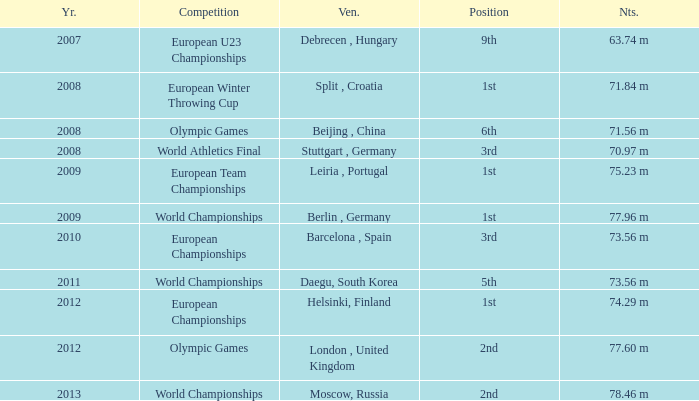Which Year has a Position of 9th? 2007.0. 